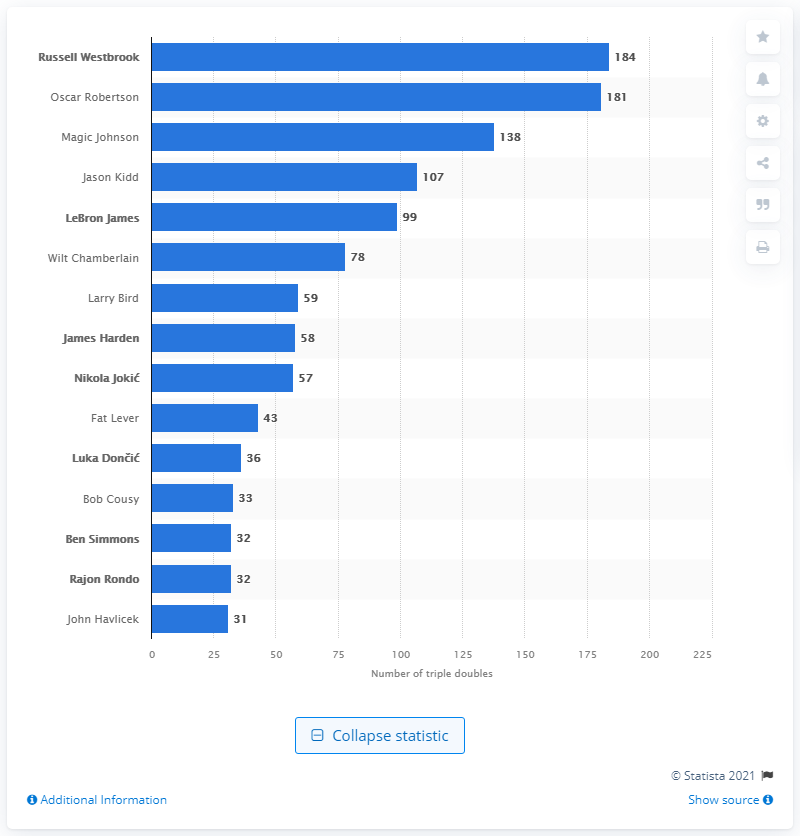List a handful of essential elements in this visual. Without a doubt, Russell Westbrook is the undisputed king of the triple doubles. It is a well-known fact that Oscar Robertson holds the record for triple doubles in the National Basketball Association. 